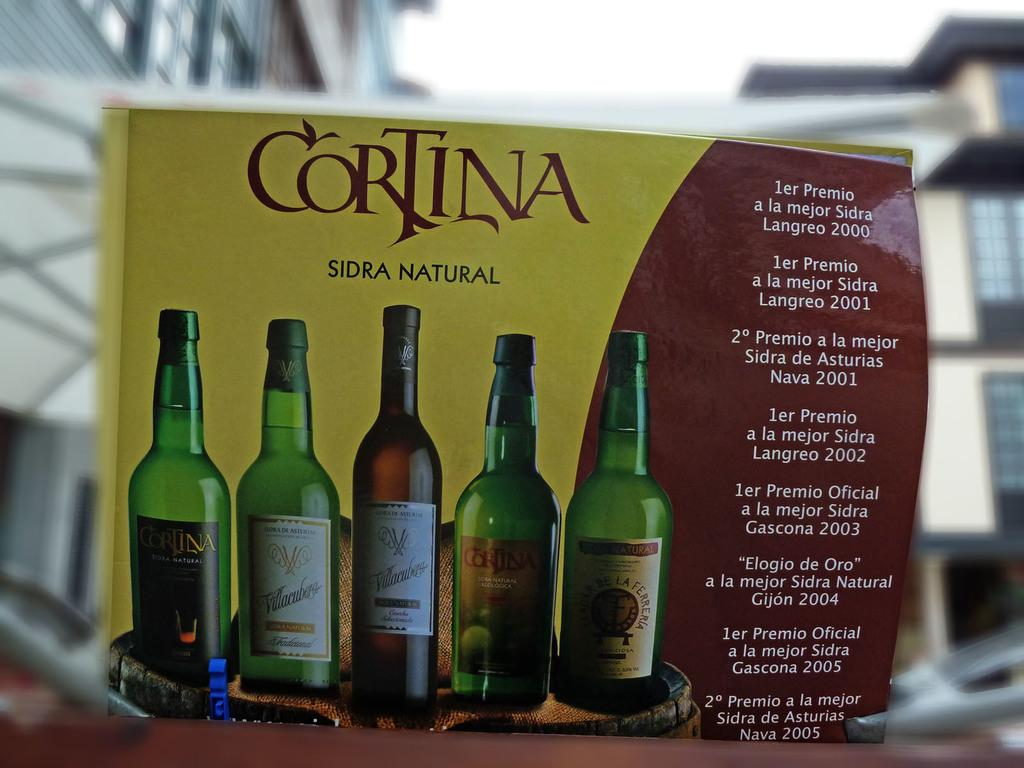<image>
Provide a brief description of the given image. A red and yellow box for Cortina Sidra Natural. 